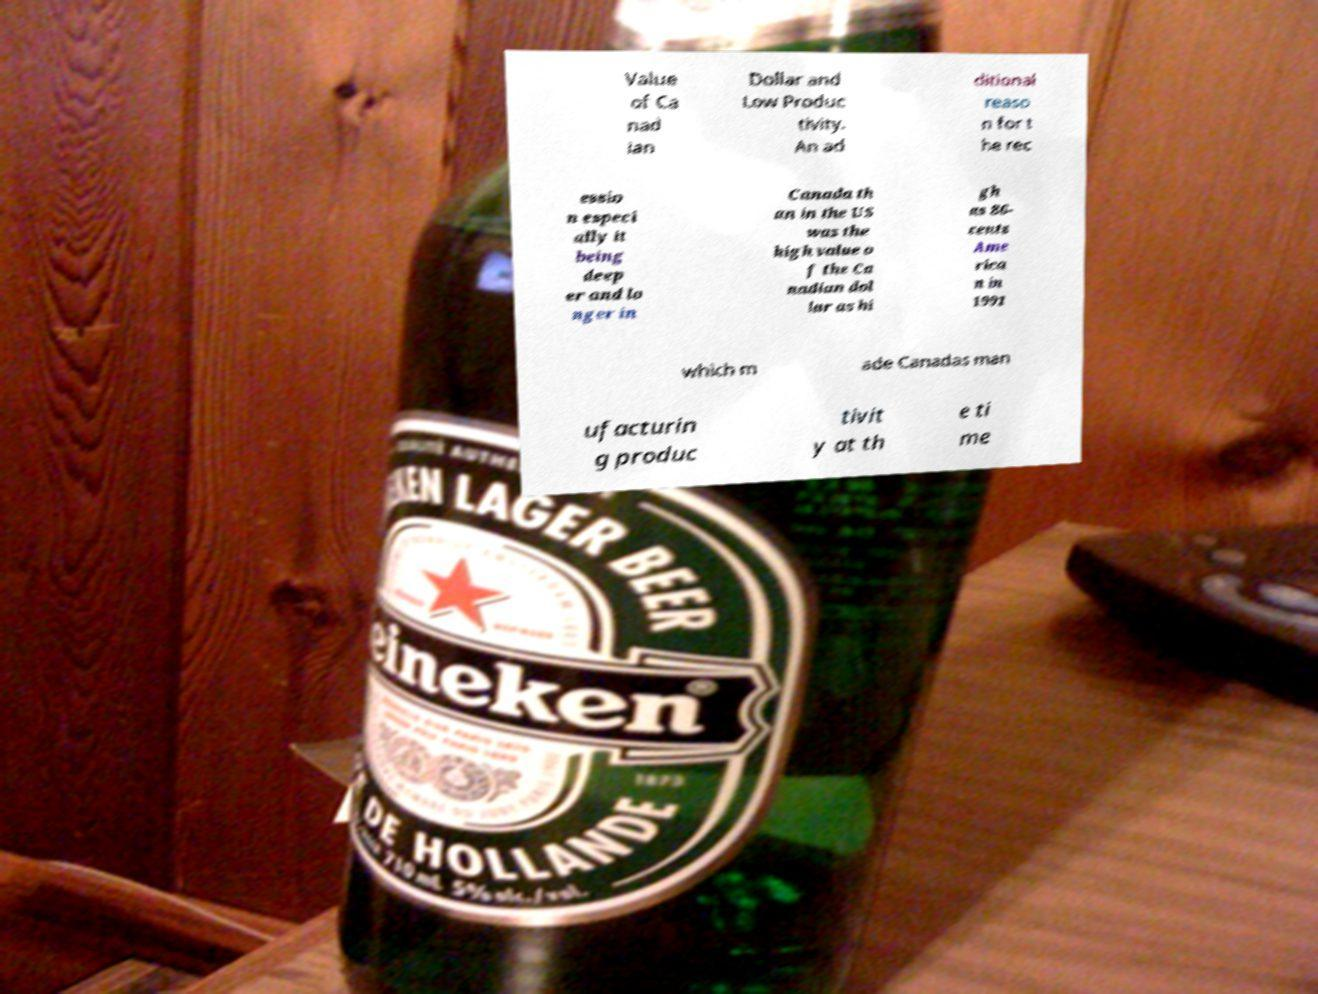Can you read and provide the text displayed in the image?This photo seems to have some interesting text. Can you extract and type it out for me? Value of Ca nad ian Dollar and Low Produc tivity. An ad ditional reaso n for t he rec essio n especi ally it being deep er and lo nger in Canada th an in the US was the high value o f the Ca nadian dol lar as hi gh as 86- cents Ame rica n in 1991 which m ade Canadas man ufacturin g produc tivit y at th e ti me 